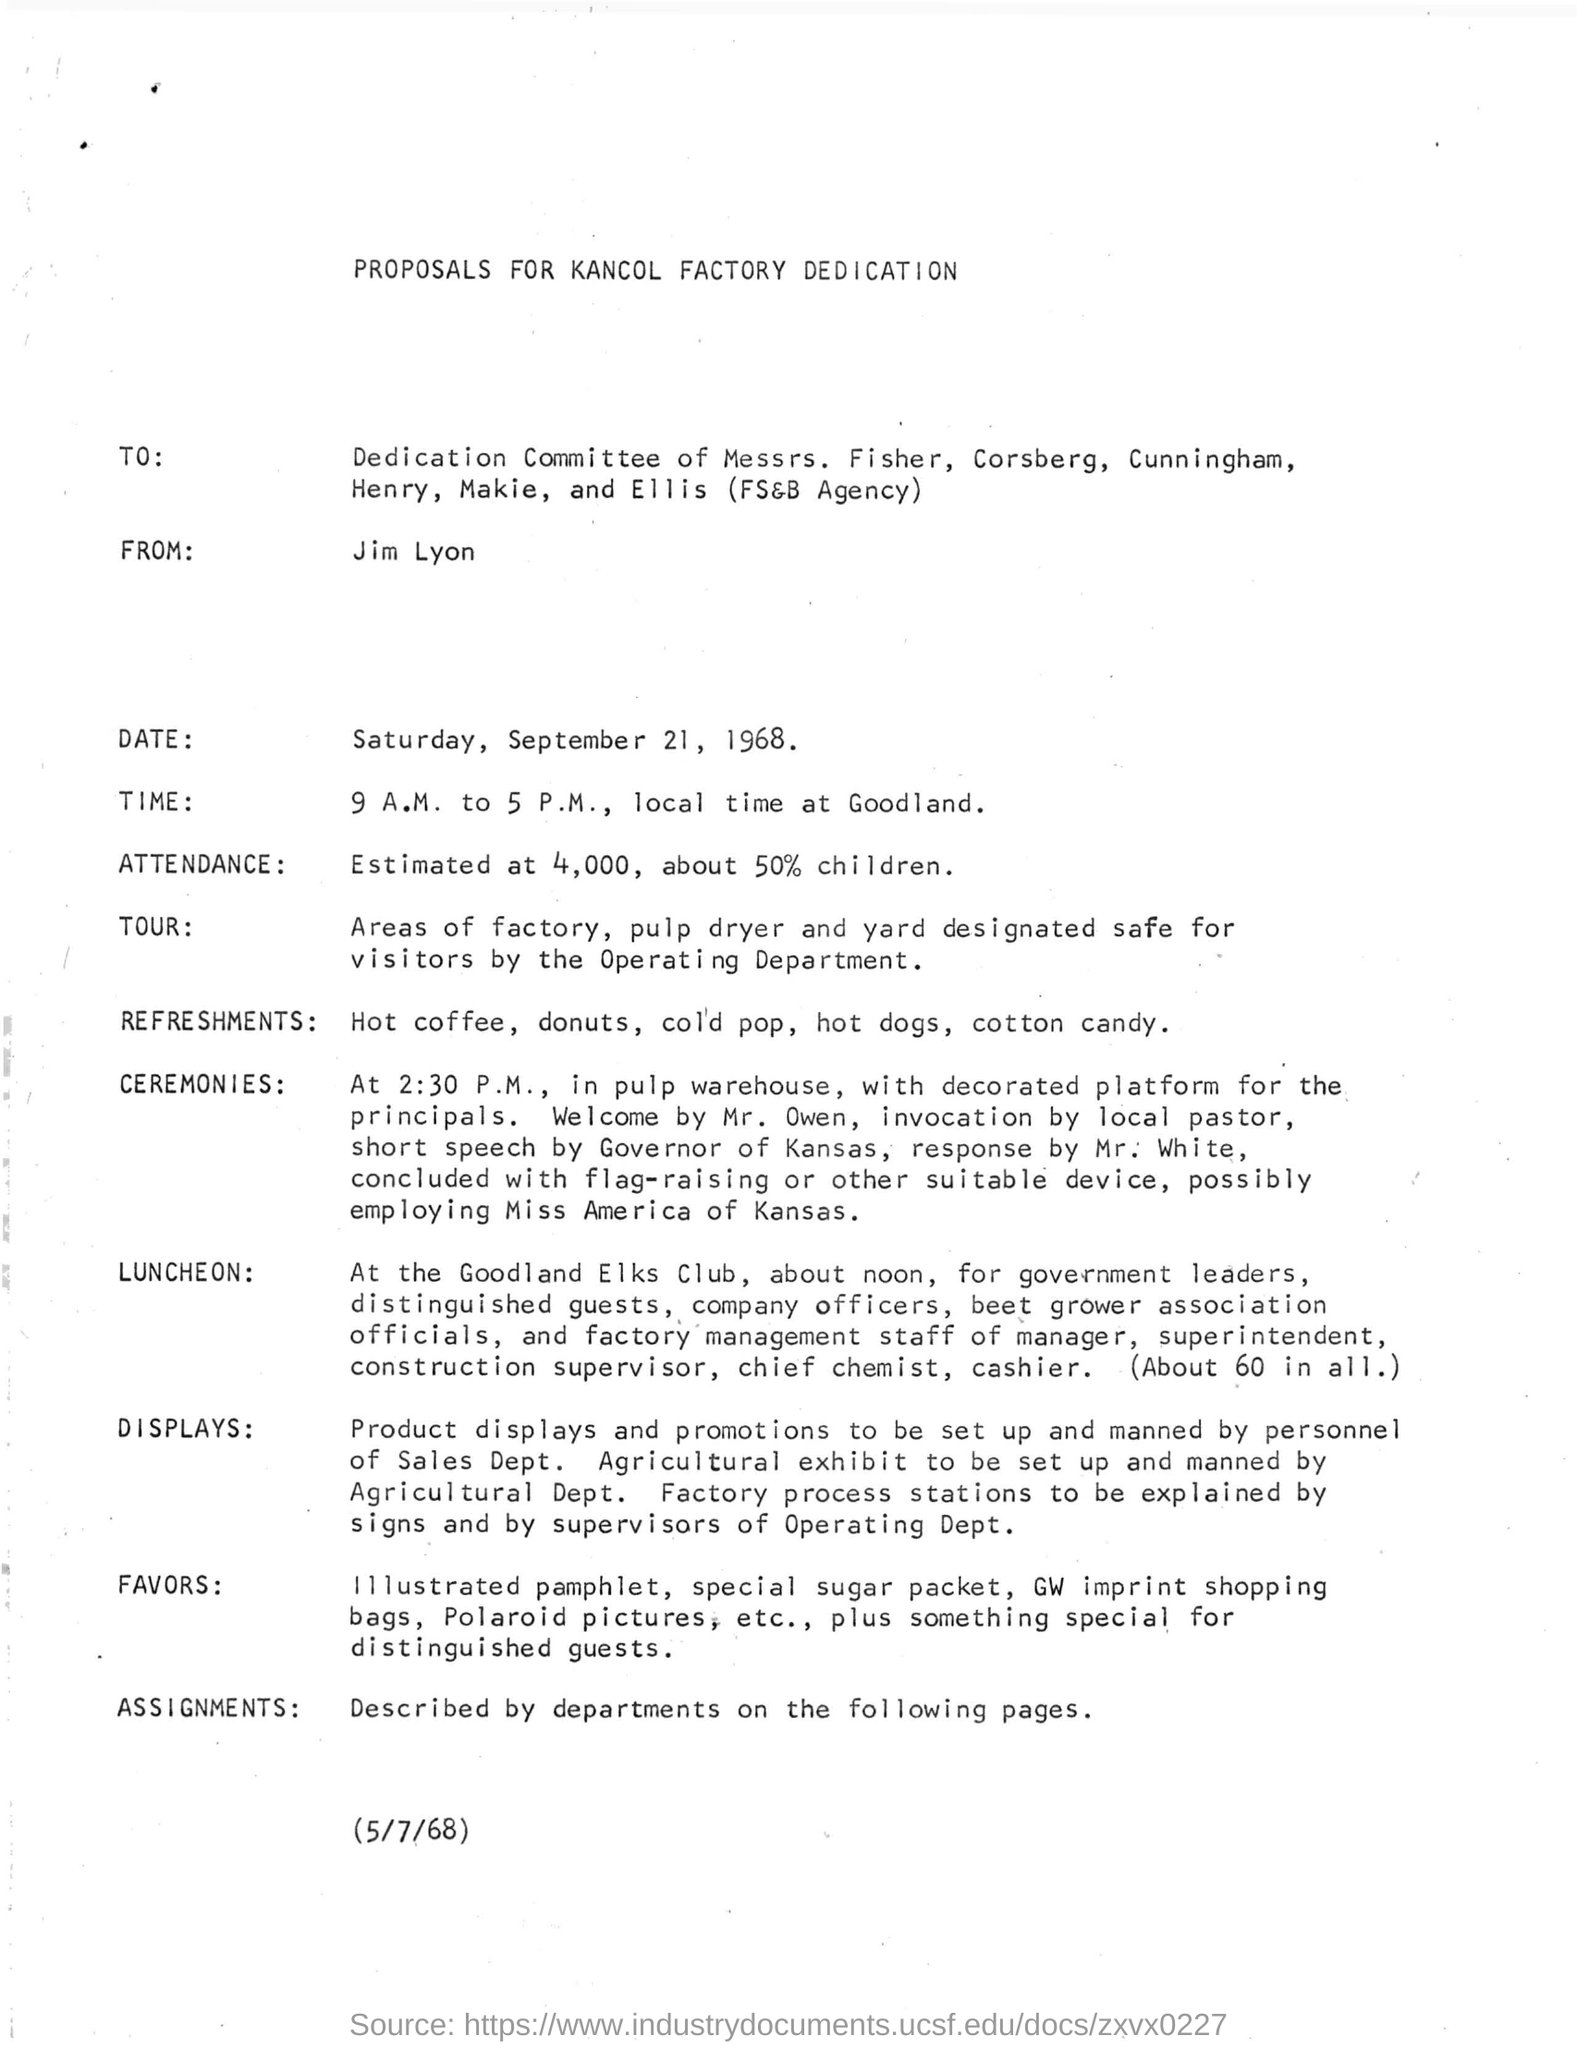Mention a couple of crucial points in this snapshot. The person who initiates or begins a ceremony is MR. OWEN. The sender of the proposal is Jim Lyon. The LUNCHEON will be held at the Goodland Elks Club. 